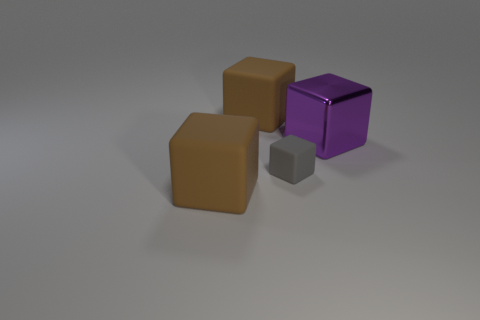Is there any other thing that is the same size as the gray object?
Ensure brevity in your answer.  No. Does the brown rubber block in front of the big shiny thing have the same size as the matte block behind the gray matte block?
Provide a succinct answer. Yes. There is a brown rubber object that is behind the purple shiny object; what size is it?
Your answer should be compact. Large. Are there any big cubes that have the same color as the big shiny thing?
Your answer should be compact. No. Are there any things in front of the rubber cube that is in front of the tiny gray object?
Offer a terse response. No. There is a purple shiny cube; is its size the same as the brown block that is behind the purple metallic block?
Give a very brief answer. Yes. There is a large brown matte object in front of the big brown object that is behind the tiny rubber object; are there any big purple things that are on the left side of it?
Give a very brief answer. No. What is the material of the large thing in front of the tiny matte cube?
Your response must be concise. Rubber. Does the purple cube have the same size as the gray object?
Ensure brevity in your answer.  No. There is a big thing that is behind the tiny block and to the left of the metallic block; what is its color?
Give a very brief answer. Brown. 